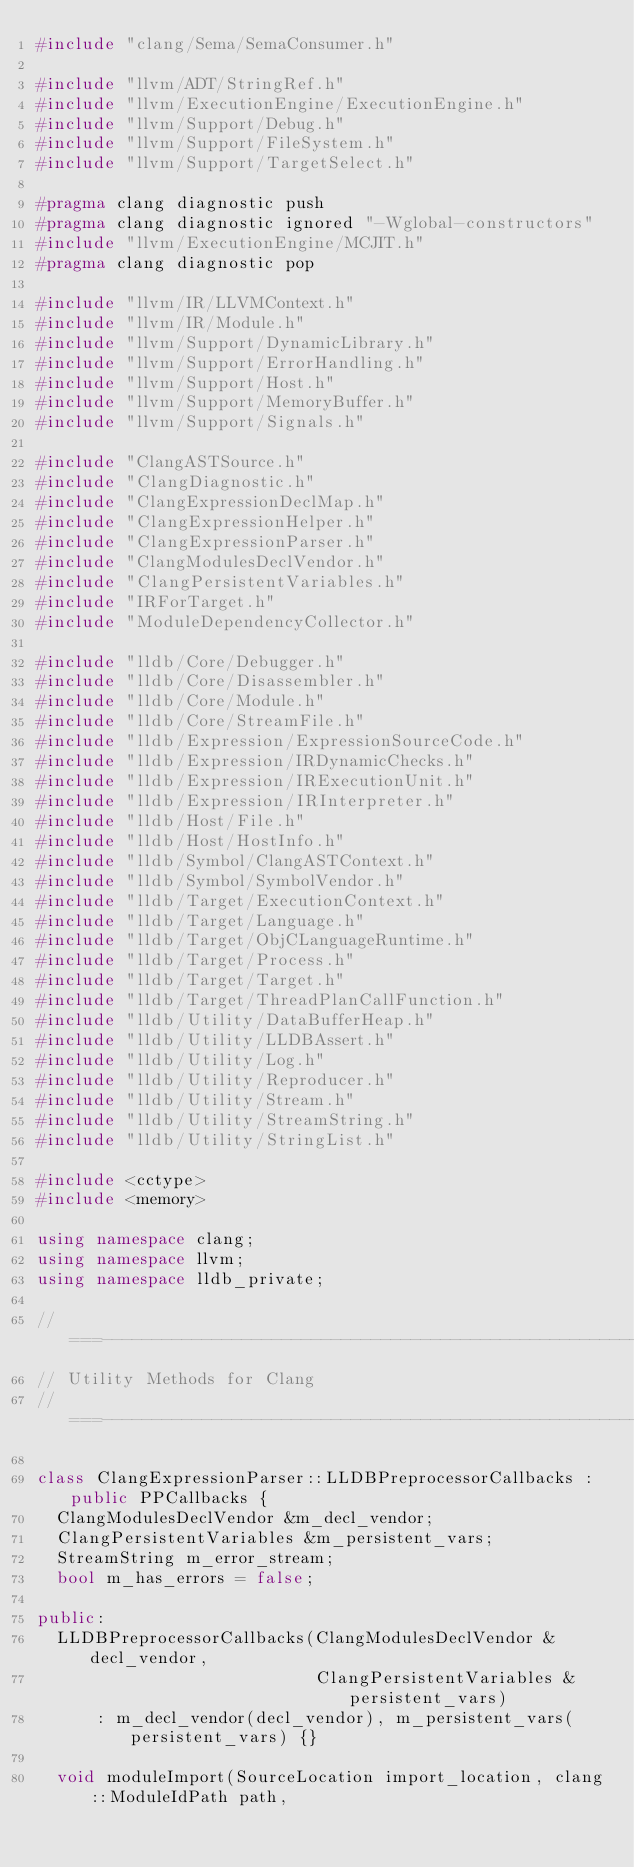Convert code to text. <code><loc_0><loc_0><loc_500><loc_500><_C++_>#include "clang/Sema/SemaConsumer.h"

#include "llvm/ADT/StringRef.h"
#include "llvm/ExecutionEngine/ExecutionEngine.h"
#include "llvm/Support/Debug.h"
#include "llvm/Support/FileSystem.h"
#include "llvm/Support/TargetSelect.h"

#pragma clang diagnostic push
#pragma clang diagnostic ignored "-Wglobal-constructors"
#include "llvm/ExecutionEngine/MCJIT.h"
#pragma clang diagnostic pop

#include "llvm/IR/LLVMContext.h"
#include "llvm/IR/Module.h"
#include "llvm/Support/DynamicLibrary.h"
#include "llvm/Support/ErrorHandling.h"
#include "llvm/Support/Host.h"
#include "llvm/Support/MemoryBuffer.h"
#include "llvm/Support/Signals.h"

#include "ClangASTSource.h"
#include "ClangDiagnostic.h"
#include "ClangExpressionDeclMap.h"
#include "ClangExpressionHelper.h"
#include "ClangExpressionParser.h"
#include "ClangModulesDeclVendor.h"
#include "ClangPersistentVariables.h"
#include "IRForTarget.h"
#include "ModuleDependencyCollector.h"

#include "lldb/Core/Debugger.h"
#include "lldb/Core/Disassembler.h"
#include "lldb/Core/Module.h"
#include "lldb/Core/StreamFile.h"
#include "lldb/Expression/ExpressionSourceCode.h"
#include "lldb/Expression/IRDynamicChecks.h"
#include "lldb/Expression/IRExecutionUnit.h"
#include "lldb/Expression/IRInterpreter.h"
#include "lldb/Host/File.h"
#include "lldb/Host/HostInfo.h"
#include "lldb/Symbol/ClangASTContext.h"
#include "lldb/Symbol/SymbolVendor.h"
#include "lldb/Target/ExecutionContext.h"
#include "lldb/Target/Language.h"
#include "lldb/Target/ObjCLanguageRuntime.h"
#include "lldb/Target/Process.h"
#include "lldb/Target/Target.h"
#include "lldb/Target/ThreadPlanCallFunction.h"
#include "lldb/Utility/DataBufferHeap.h"
#include "lldb/Utility/LLDBAssert.h"
#include "lldb/Utility/Log.h"
#include "lldb/Utility/Reproducer.h"
#include "lldb/Utility/Stream.h"
#include "lldb/Utility/StreamString.h"
#include "lldb/Utility/StringList.h"

#include <cctype>
#include <memory>

using namespace clang;
using namespace llvm;
using namespace lldb_private;

//===----------------------------------------------------------------------===//
// Utility Methods for Clang
//===----------------------------------------------------------------------===//

class ClangExpressionParser::LLDBPreprocessorCallbacks : public PPCallbacks {
  ClangModulesDeclVendor &m_decl_vendor;
  ClangPersistentVariables &m_persistent_vars;
  StreamString m_error_stream;
  bool m_has_errors = false;

public:
  LLDBPreprocessorCallbacks(ClangModulesDeclVendor &decl_vendor,
                            ClangPersistentVariables &persistent_vars)
      : m_decl_vendor(decl_vendor), m_persistent_vars(persistent_vars) {}

  void moduleImport(SourceLocation import_location, clang::ModuleIdPath path,</code> 